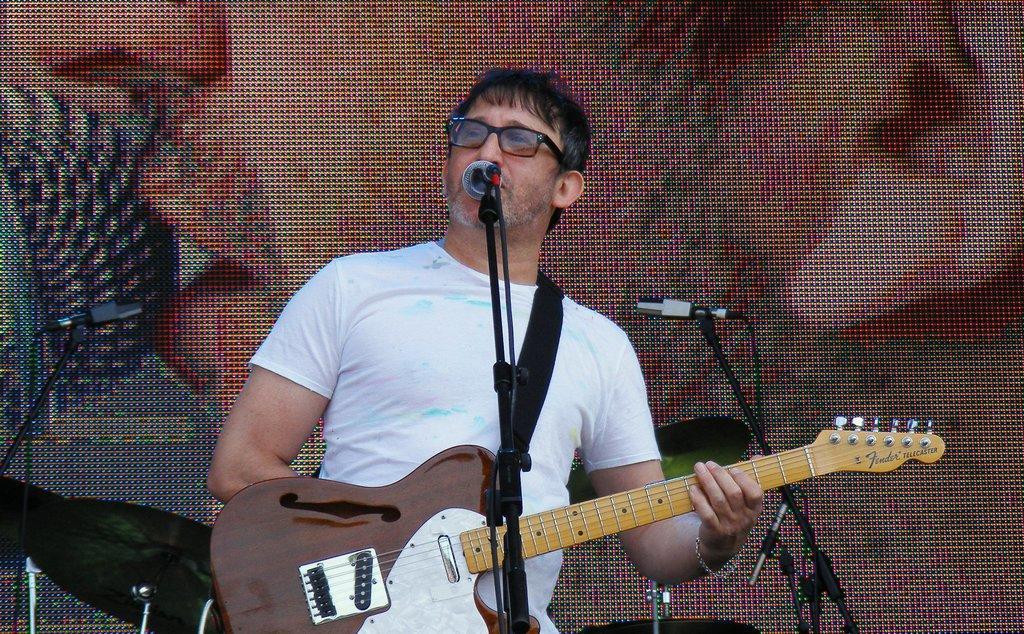Could you give a brief overview of what you see in this image? In the center of the image there is a man standing and holding a guitar in his hand. There is a mic before him. In the background there is a screen. 